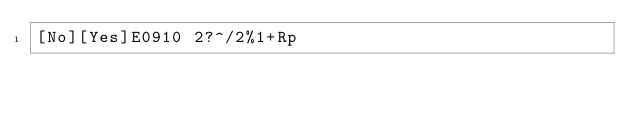Convert code to text. <code><loc_0><loc_0><loc_500><loc_500><_dc_>[No][Yes]E0910 2?^/2%1+Rp</code> 